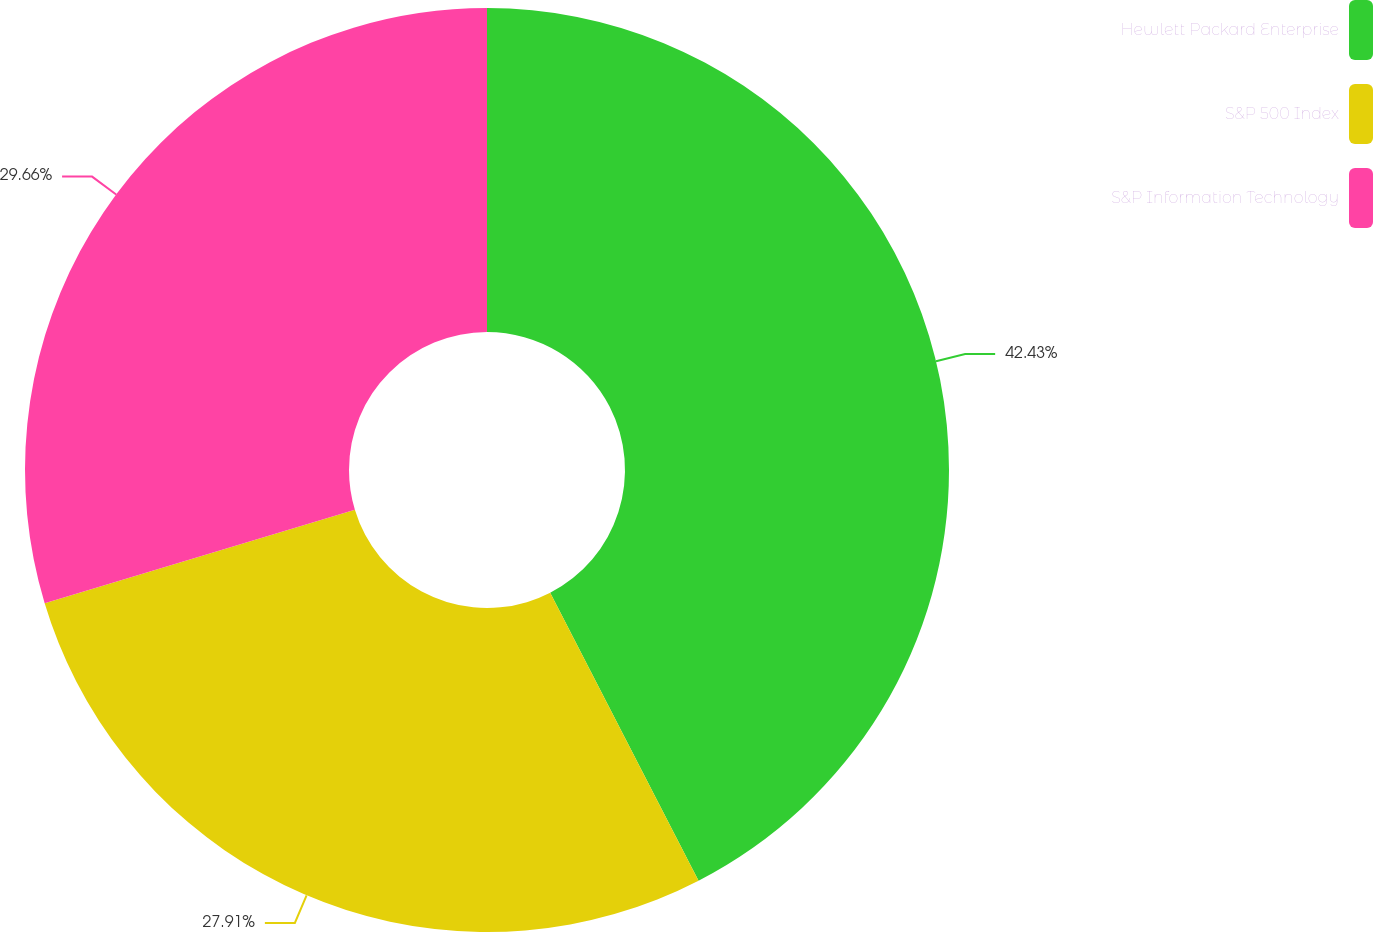Convert chart. <chart><loc_0><loc_0><loc_500><loc_500><pie_chart><fcel>Hewlett Packard Enterprise<fcel>S&P 500 Index<fcel>S&P Information Technology<nl><fcel>42.43%<fcel>27.91%<fcel>29.66%<nl></chart> 